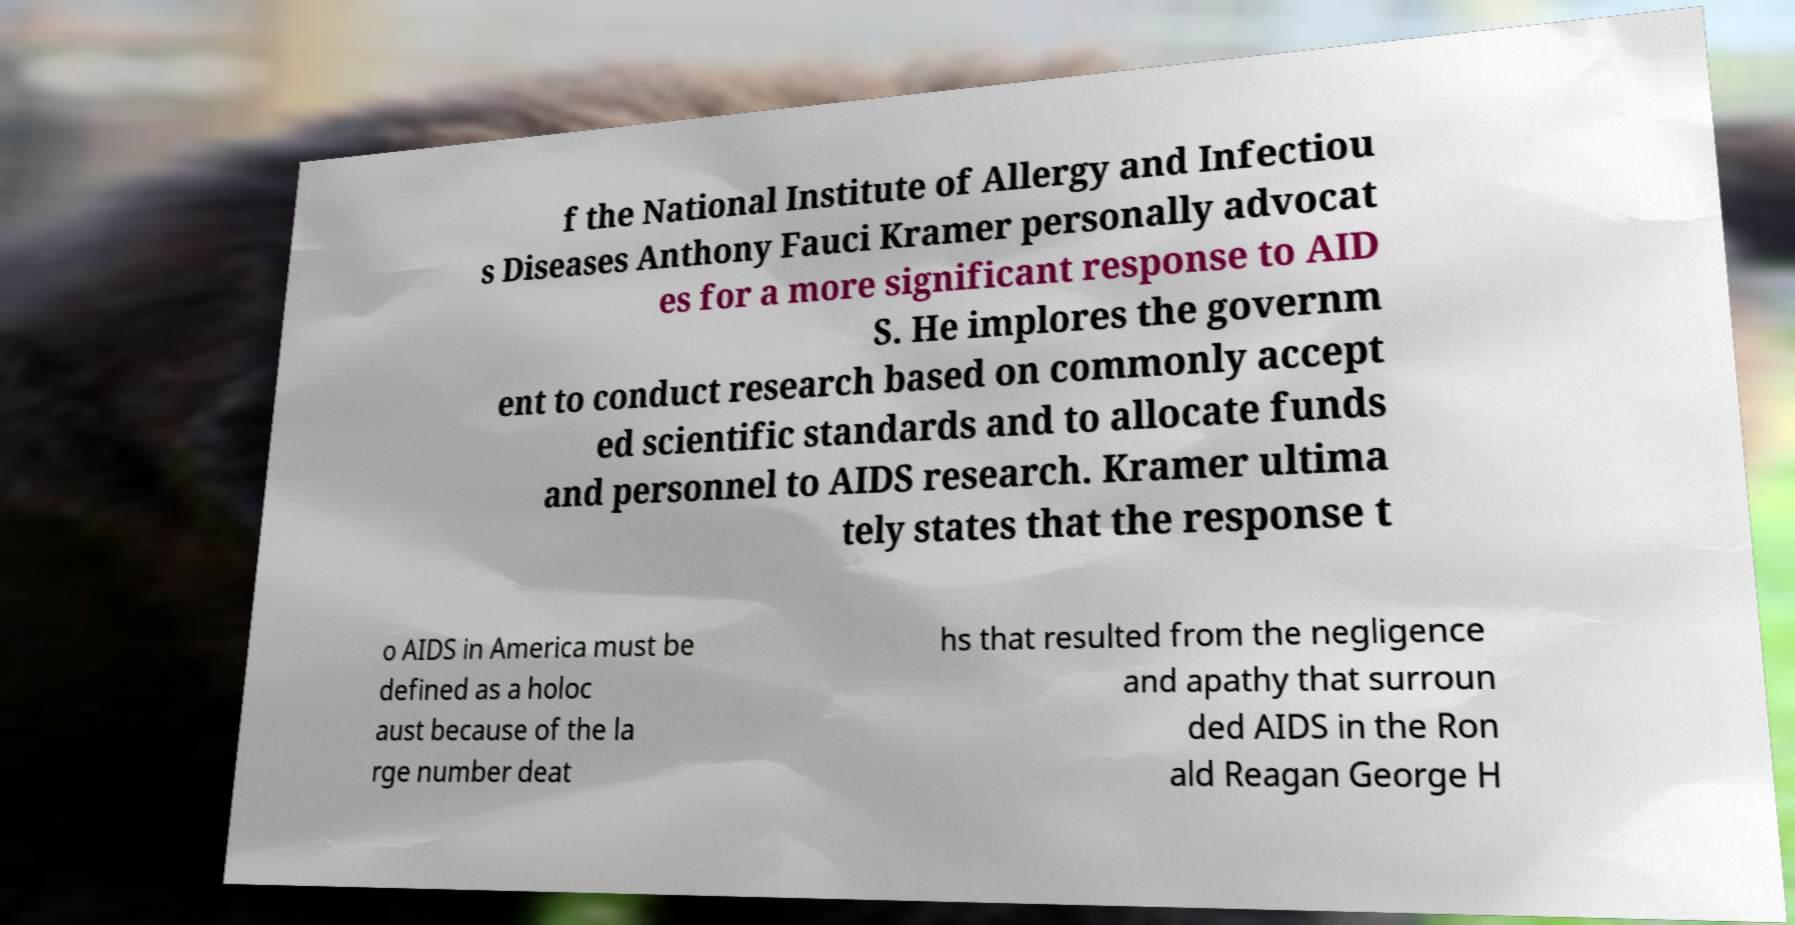Could you assist in decoding the text presented in this image and type it out clearly? f the National Institute of Allergy and Infectiou s Diseases Anthony Fauci Kramer personally advocat es for a more significant response to AID S. He implores the governm ent to conduct research based on commonly accept ed scientific standards and to allocate funds and personnel to AIDS research. Kramer ultima tely states that the response t o AIDS in America must be defined as a holoc aust because of the la rge number deat hs that resulted from the negligence and apathy that surroun ded AIDS in the Ron ald Reagan George H 